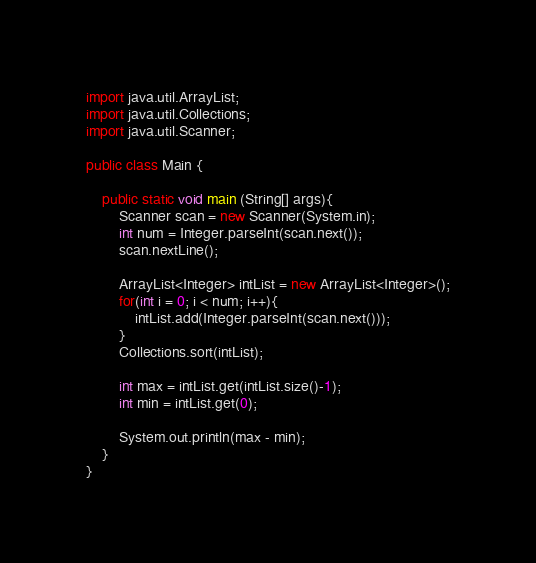<code> <loc_0><loc_0><loc_500><loc_500><_Java_>import java.util.ArrayList;
import java.util.Collections;
import java.util.Scanner;

public class Main {

	public static void main (String[] args){
	    Scanner scan = new Scanner(System.in);
	    int num = Integer.parseInt(scan.next());
	    scan.nextLine();

	    ArrayList<Integer> intList = new ArrayList<Integer>();
	    for(int i = 0; i < num; i++){
	    	intList.add(Integer.parseInt(scan.next()));
	    }
	    Collections.sort(intList);

	    int max = intList.get(intList.size()-1);
	    int min = intList.get(0);

	    System.out.println(max - min);
	}
}</code> 